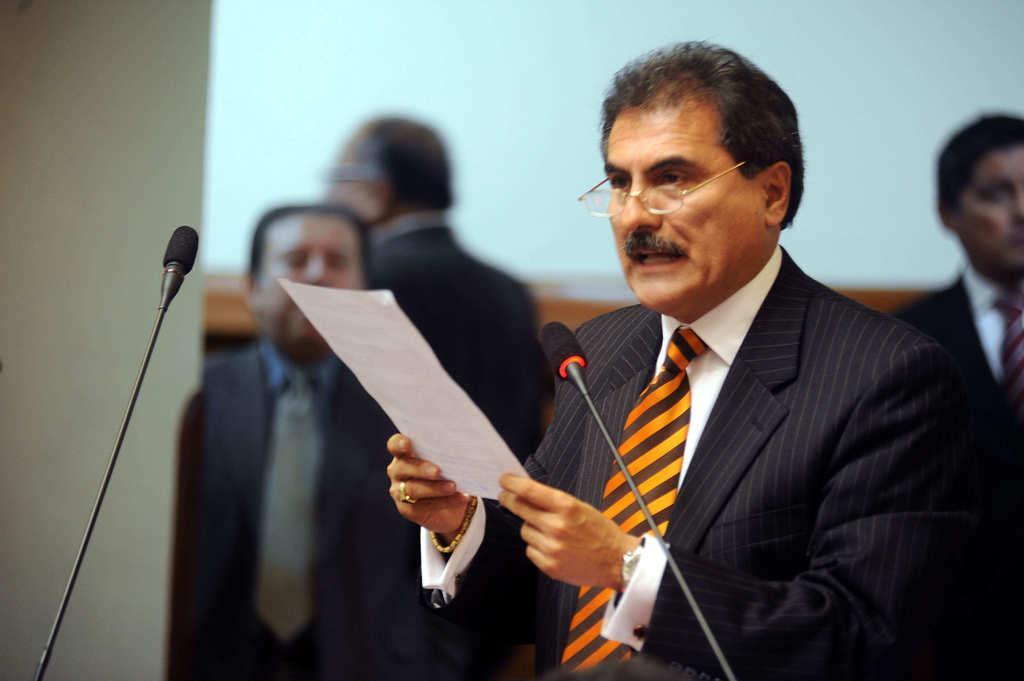Describe this image in one or two sentences. In this image I can see group of people standing. In front the person is wearing black blazer, white shirt and holding the paper and I can also see two microphones. In the background the wall is in white color. 